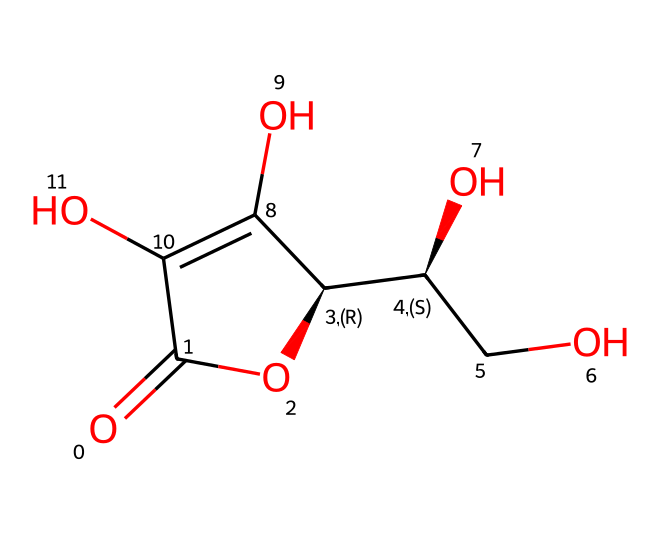What is the common name for the chemical represented by this SMILES? The SMILES corresponds to ascorbic acid, commonly known as vitamin C. This is because the structural arrangement and functional groups (specifically the hydroxyl and carbonyl groups) are characteristic of ascorbic acid.
Answer: vitamin C How many carbon atoms are present in the structure? By examining the SMILES representation, we can count the carbon atoms indicated by the 'C' notations within the structure. There are six carbons visible in the molecular structure.
Answer: six What type of functional groups are present in vitamin C? The structure displays hydroxyl (-OH) and carbonyl (>C=O) functional groups, which are typical for alcohols and ketones, respectively. These groups are essential to the chemical reactivity of vitamin C.
Answer: hydroxyl and carbonyl What is the molecular formula of vitamin C? To determine the molecular formula, we systematically count all the atoms as depicted in the chemical structure. In total, vitamin C comprises six carbon atoms, eight hydrogen atoms, and six oxygen atoms, resulting in a formula of C6H8O6.
Answer: C6H8O6 How does the structure relate to its antioxidant properties? The presence of multiple hydroxyl groups (-OH) in the structure is responsible for vitamin C's ability to donate electrons. This electron donation helps neutralize free radicals, providing antioxidant properties. The arrangement of the hydroxyl groups plays a crucial role in this activity.
Answer: antioxidant properties In what way does vitamin C influence stress management? Vitamin C is known to support the adrenal glands by regulating cortisol levels, and its antioxidant properties can mitigate oxidative stress within the body. This regulation helps in maintaining overall stress levels.
Answer: regulates cortisol levels 